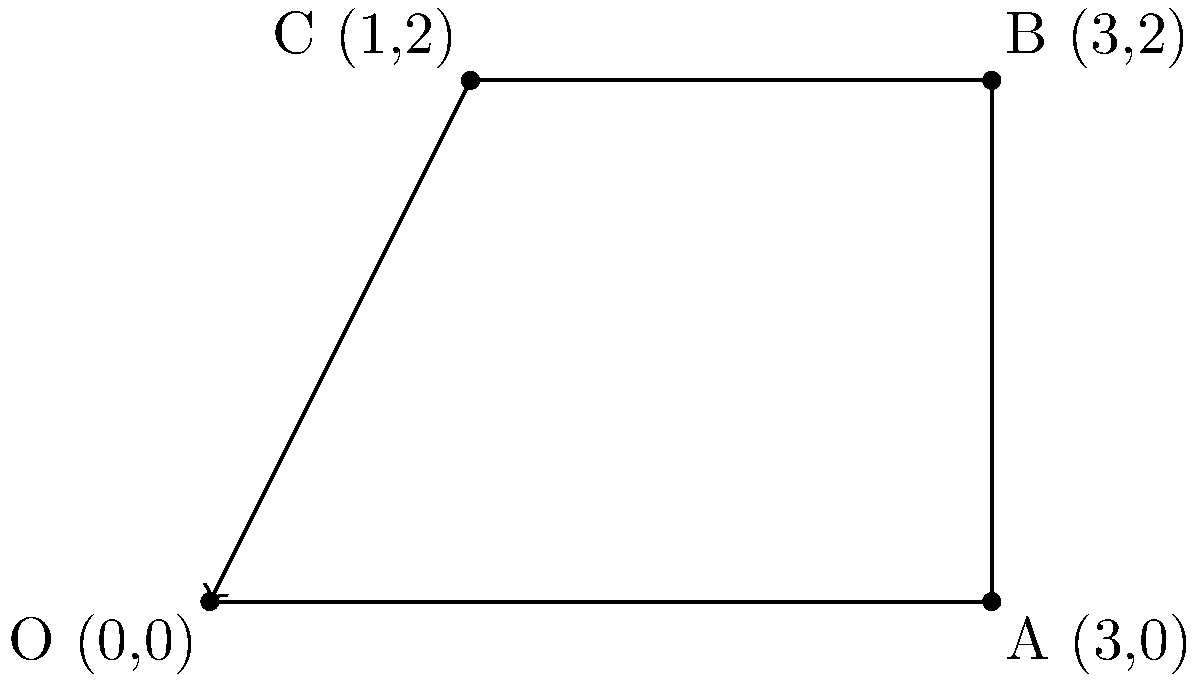As the father of the bride, you're showcasing your smooth dance moves at the wedding reception. You start at the origin (0,0) and perform a series of three dance steps represented by vectors. Step 1 is 3 units east, Step 2 is 2 units north, and Step 3 is 2 units west. What is your final position after completing these dance moves? Let's break this down step-by-step:

1) We start at the origin (0,0).

2) Step 1: Move 3 units east
   This is represented by the vector $\vec{v_1} = (3,0)$
   New position: $(0,0) + (3,0) = (3,0)$

3) Step 2: Move 2 units north
   This is represented by the vector $\vec{v_2} = (0,2)$
   New position: $(3,0) + (0,2) = (3,2)$

4) Step 3: Move 2 units west
   This is represented by the vector $\vec{v_3} = (-2,0)$
   Final position: $(3,2) + (-2,0) = (1,2)$

5) To verify, we can add all vectors:
   $\vec{v_{total}} = \vec{v_1} + \vec{v_2} + \vec{v_3} = (3,0) + (0,2) + (-2,0) = (1,2)$

Therefore, the final position after completing these dance moves is (1,2).
Answer: (1,2) 